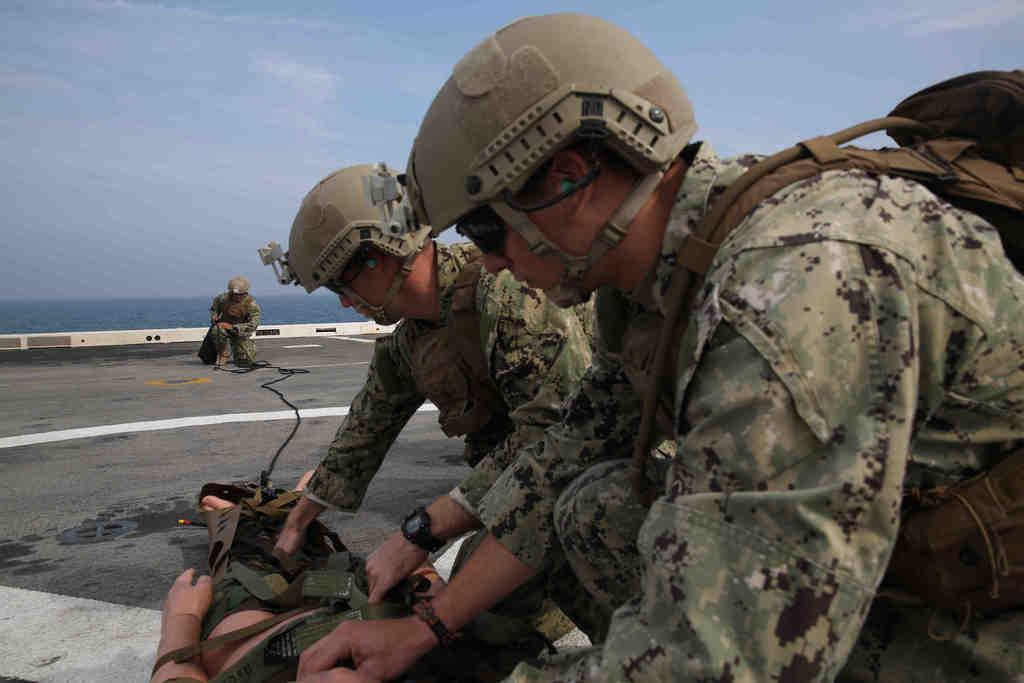Describe this image in one or two sentences. In this image we can see two combat medic. And we can see the road. And we can see the lake. And we can see the sky. 